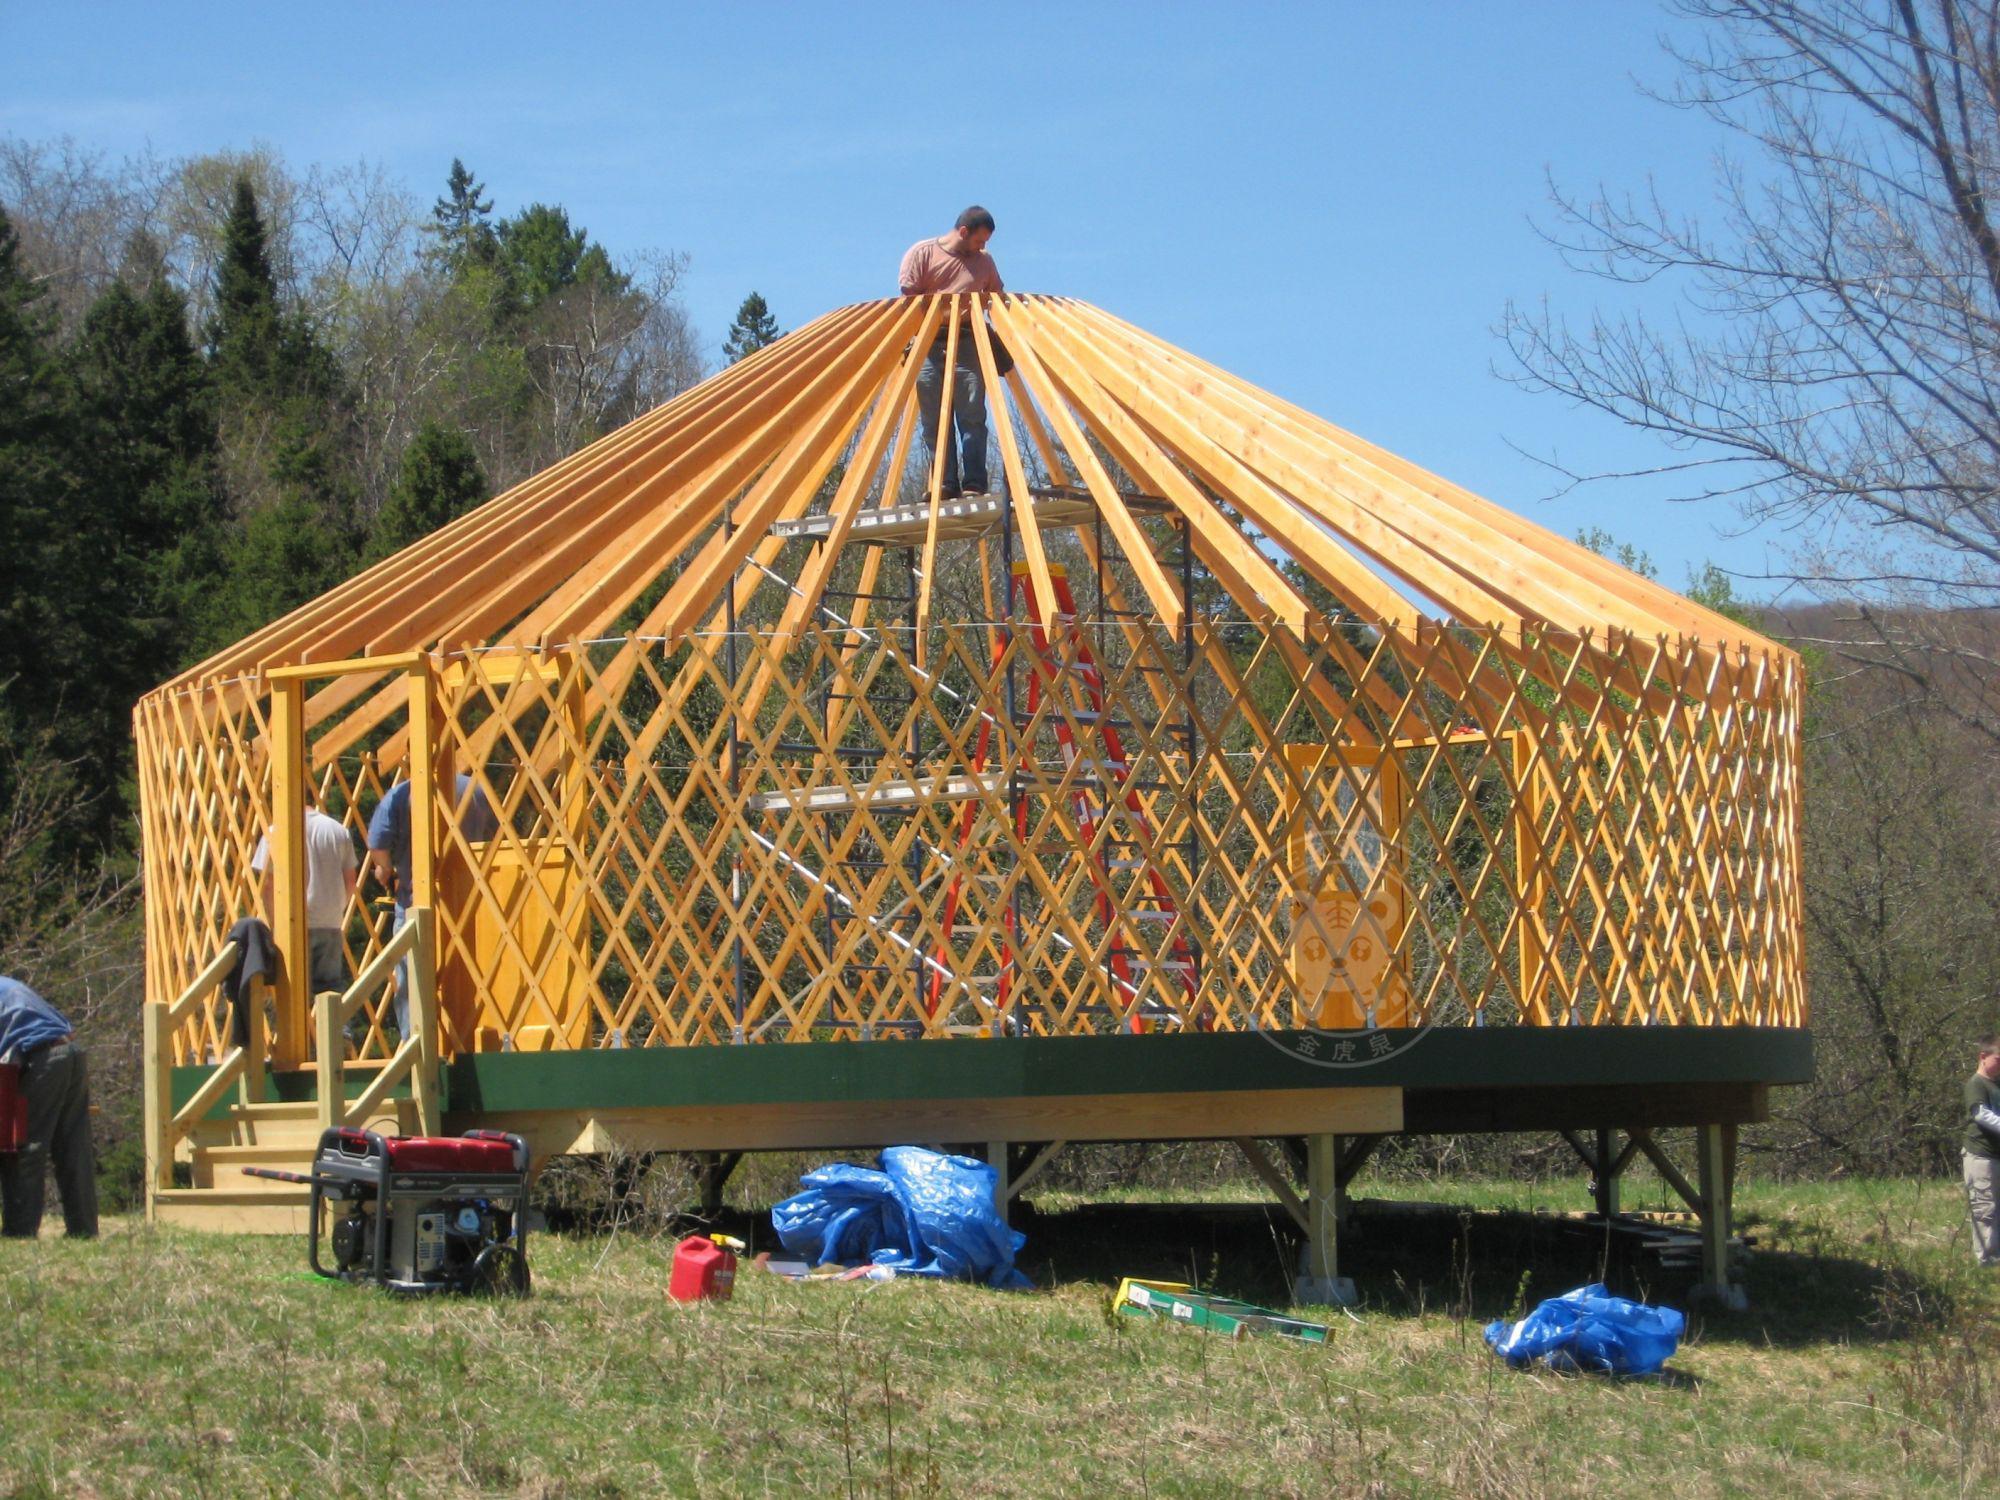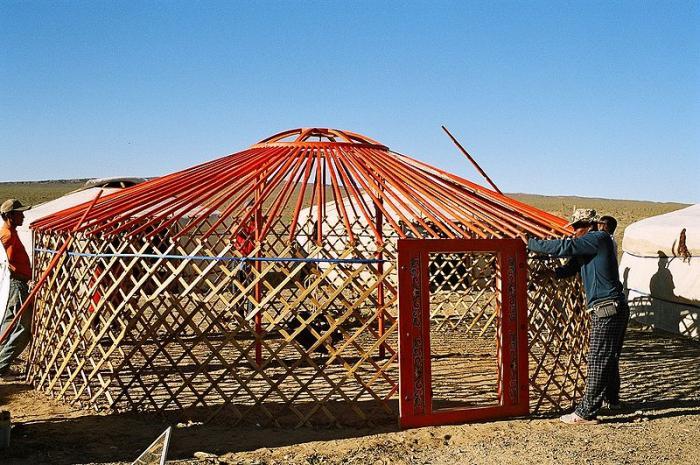The first image is the image on the left, the second image is the image on the right. Assess this claim about the two images: "At least one hut is not yet wrapped in fabric.". Correct or not? Answer yes or no. Yes. The first image is the image on the left, the second image is the image on the right. Assess this claim about the two images: "homes are in the construction phase". Correct or not? Answer yes or no. Yes. 